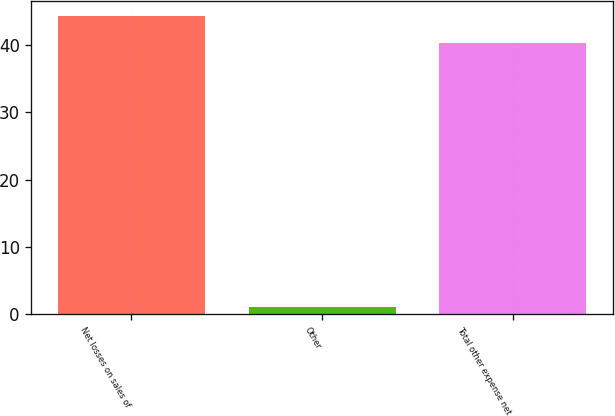Convert chart to OTSL. <chart><loc_0><loc_0><loc_500><loc_500><bar_chart><fcel>Net losses on sales of<fcel>Other<fcel>Total other expense net<nl><fcel>44.33<fcel>1.1<fcel>40.3<nl></chart> 